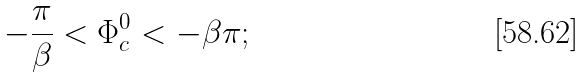Convert formula to latex. <formula><loc_0><loc_0><loc_500><loc_500>- \frac { \pi } { \beta } < \Phi _ { c } ^ { 0 } < - \beta \pi ;</formula> 